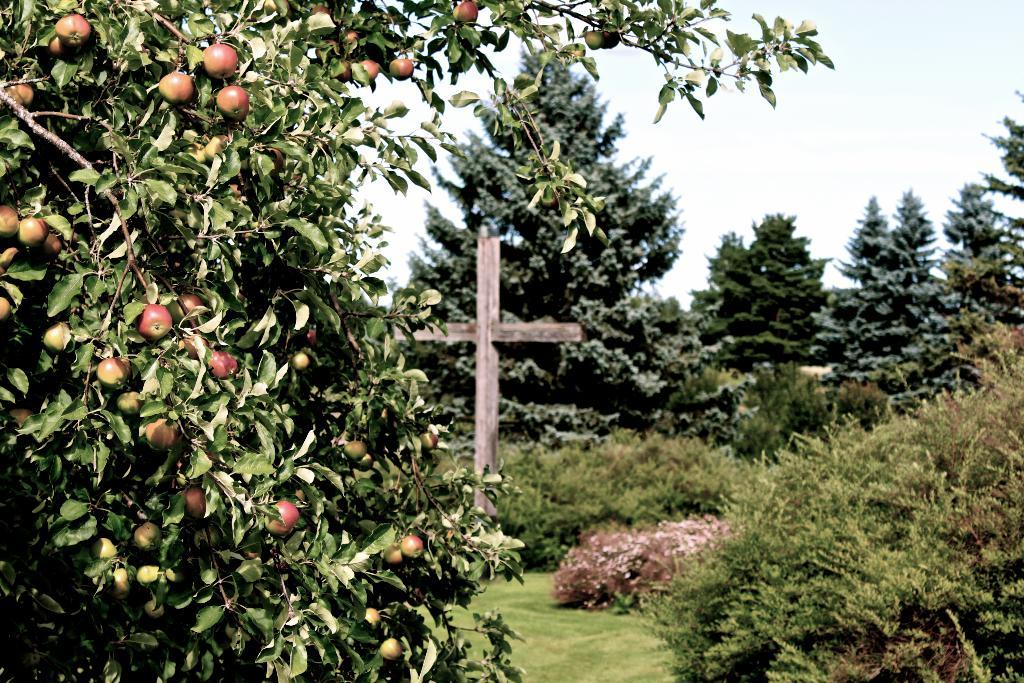What type of plants can be seen in the image? There are trees with fruits in the image. What other vegetation is present in the image? There are bushes in the image. What can be seen beneath the plants and bushes? The ground is visible in the image. What type of artwork is present in the image? There is a sculpture in the image. What is visible above the plants and sculpture? The sky is visible in the image. Who is the manager of the event taking place in the image? There is no event or manager present in the image; it features trees, bushes, ground, a sculpture, and the sky. 